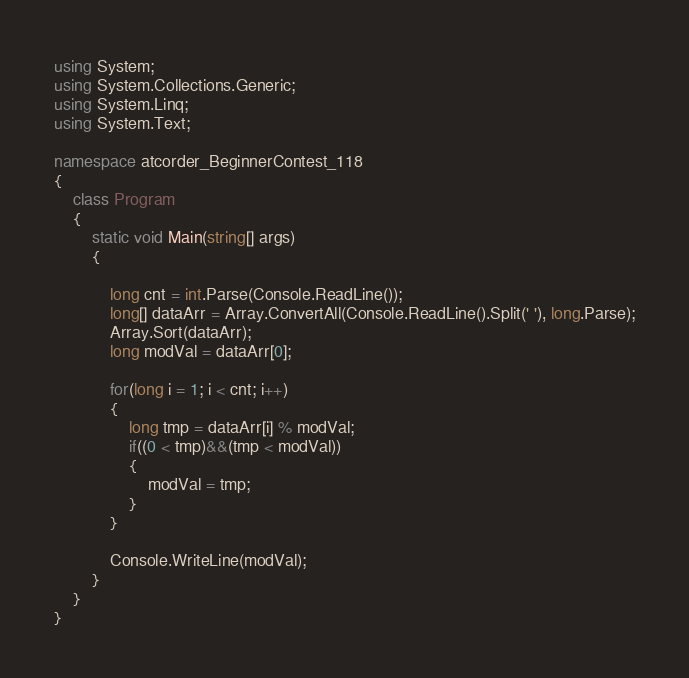<code> <loc_0><loc_0><loc_500><loc_500><_C#_>using System;
using System.Collections.Generic;
using System.Linq;
using System.Text;

namespace atcorder_BeginnerContest_118
{
    class Program
    {
        static void Main(string[] args)
        {

            long cnt = int.Parse(Console.ReadLine());
            long[] dataArr = Array.ConvertAll(Console.ReadLine().Split(' '), long.Parse);
            Array.Sort(dataArr);
            long modVal = dataArr[0];

            for(long i = 1; i < cnt; i++)
            {
                long tmp = dataArr[i] % modVal;
                if((0 < tmp)&&(tmp < modVal))
                {
                    modVal = tmp;
                }
            }

            Console.WriteLine(modVal);
        }
    }
}
</code> 